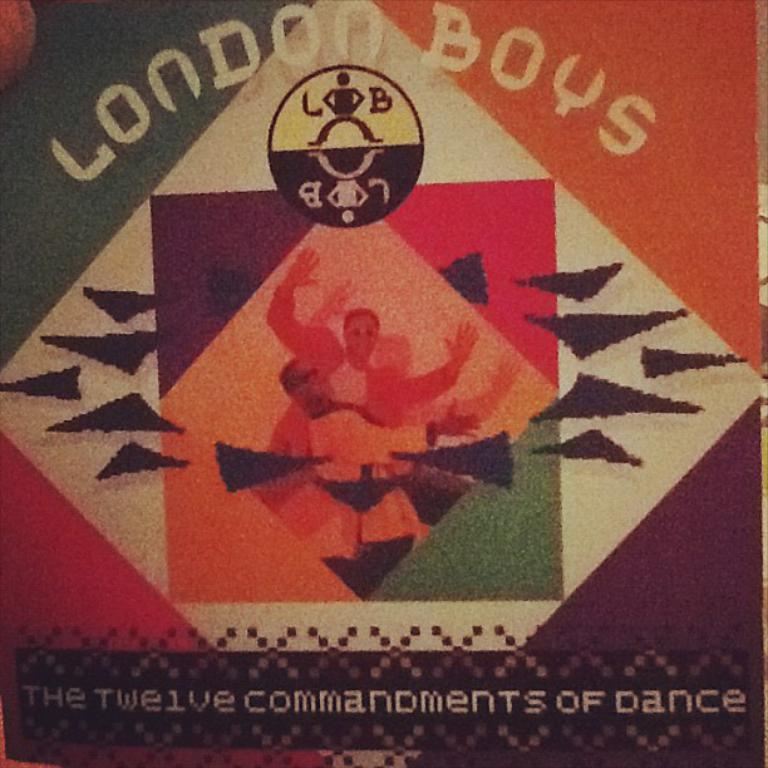<image>
Summarize the visual content of the image. An album cover of the twelve commandments of dance by the London Boys. 